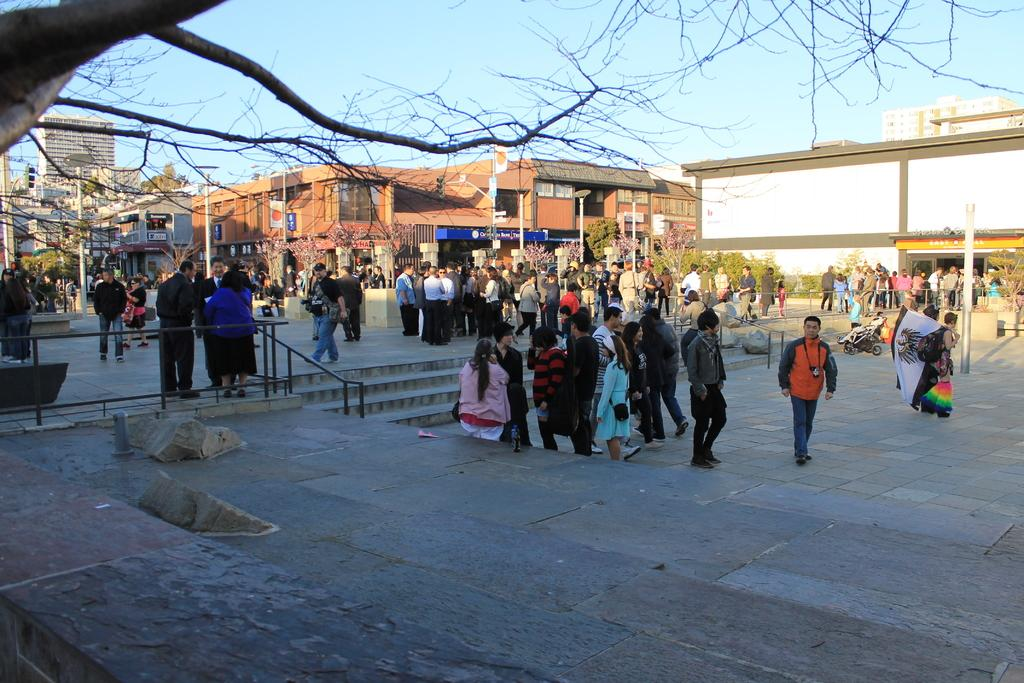What are the people in the image doing? Some people are standing, and some are walking in the image. What can be seen in the image that helps people move up or down? There are stairs in the image, which people can use to move up or down. What safety feature is present in the image? Railings are present in the image, which can provide support and safety for people using the stairs. What is visible in the background of the image? Buildings, trees, poles, and the sky are visible in the background of the image. What type of liquid is being poured from the ball in the image? There is no ball or liquid present in the image. 